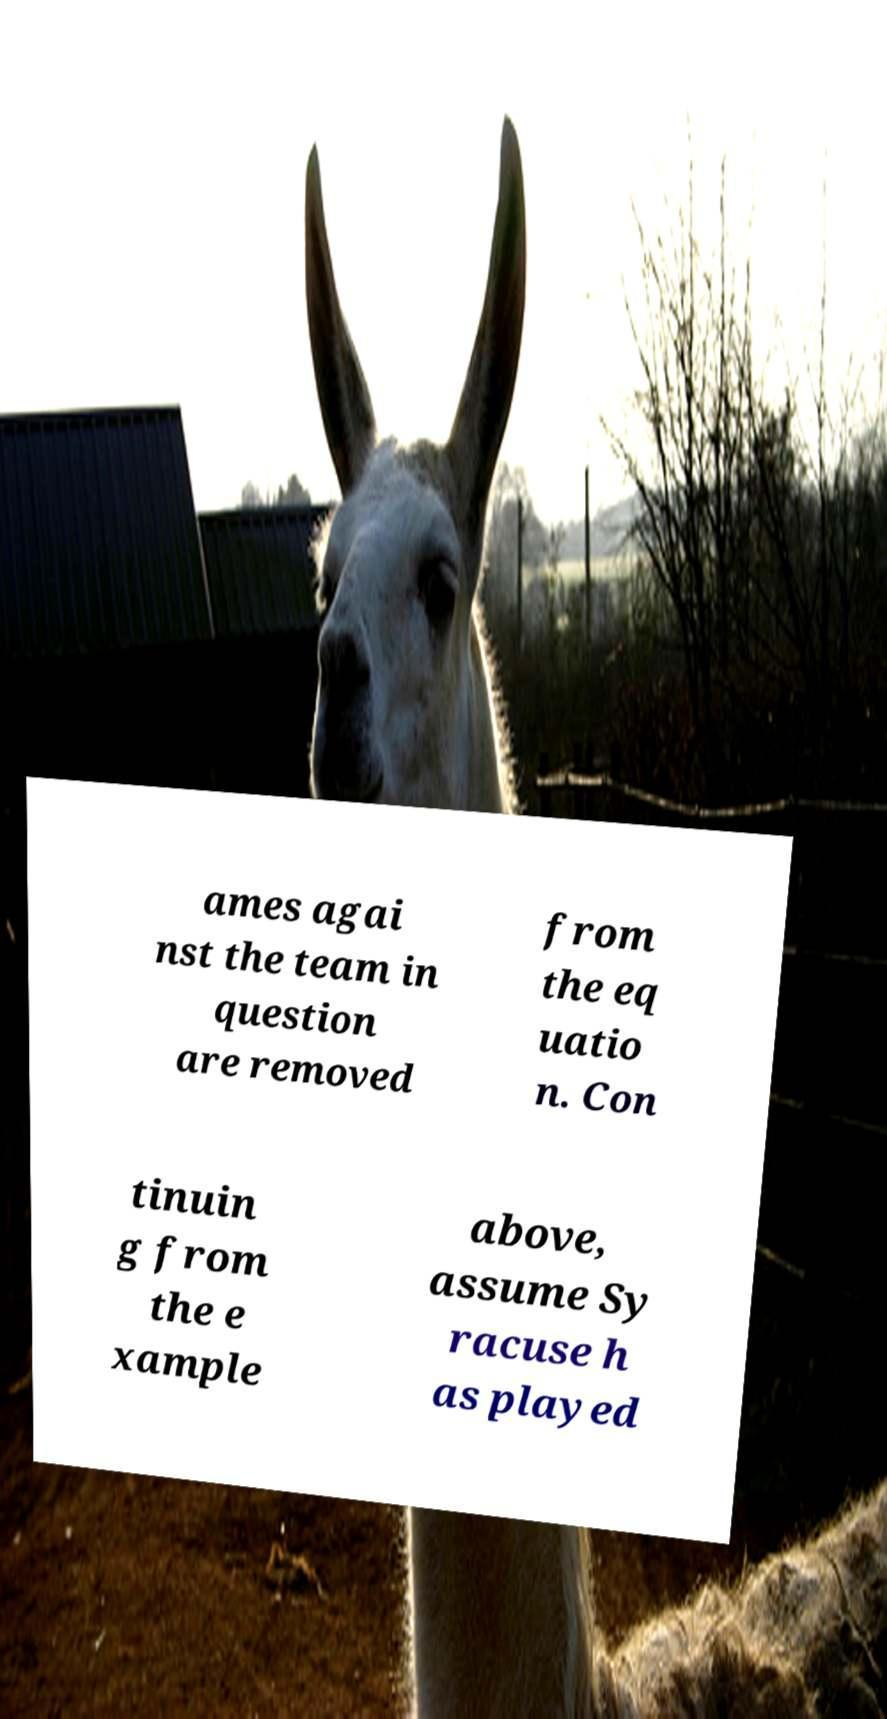What messages or text are displayed in this image? I need them in a readable, typed format. ames agai nst the team in question are removed from the eq uatio n. Con tinuin g from the e xample above, assume Sy racuse h as played 